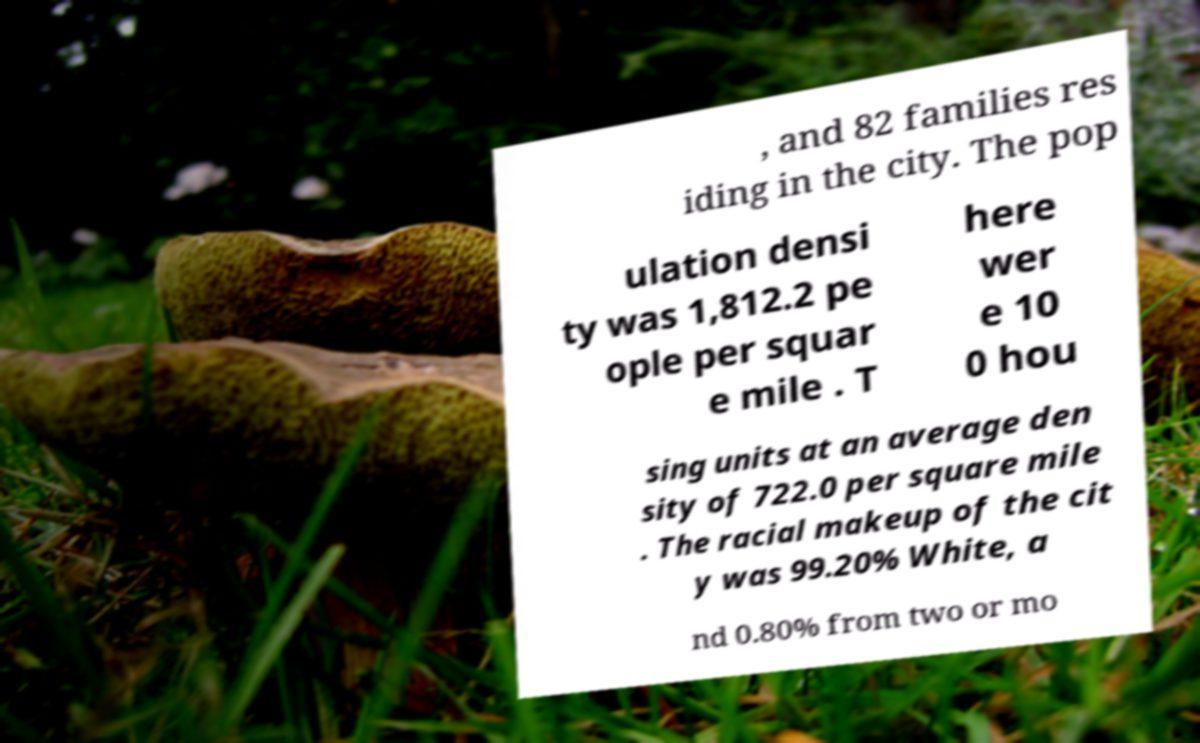What messages or text are displayed in this image? I need them in a readable, typed format. , and 82 families res iding in the city. The pop ulation densi ty was 1,812.2 pe ople per squar e mile . T here wer e 10 0 hou sing units at an average den sity of 722.0 per square mile . The racial makeup of the cit y was 99.20% White, a nd 0.80% from two or mo 